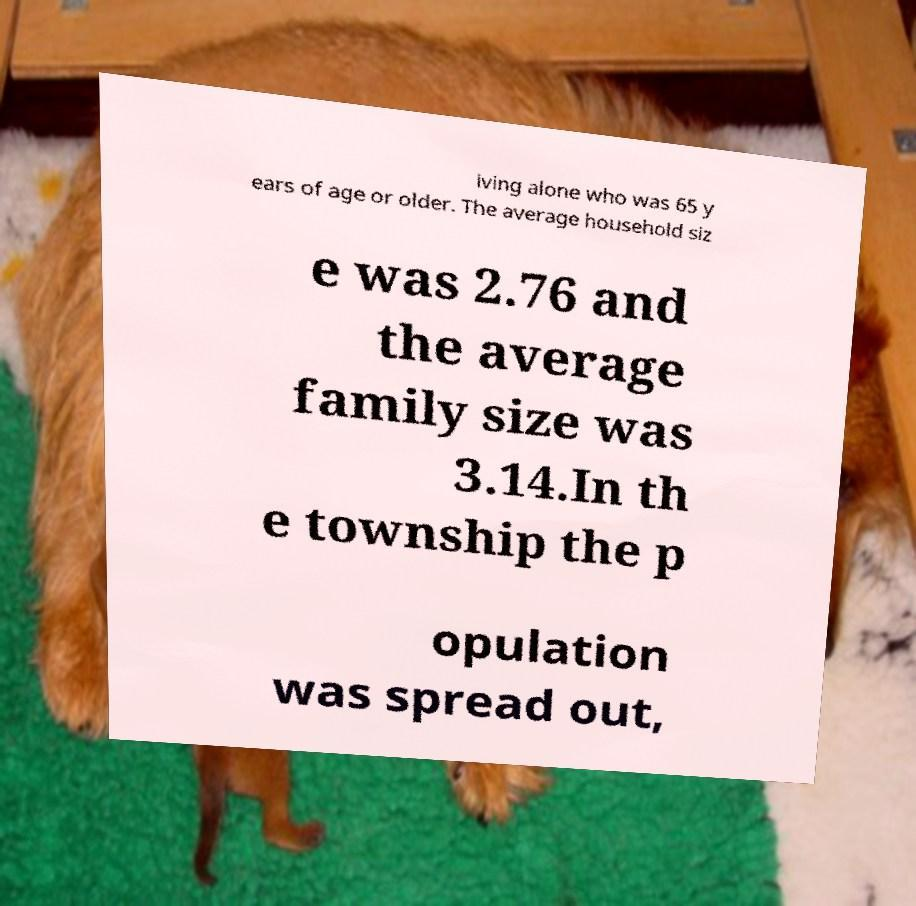Can you accurately transcribe the text from the provided image for me? iving alone who was 65 y ears of age or older. The average household siz e was 2.76 and the average family size was 3.14.In th e township the p opulation was spread out, 